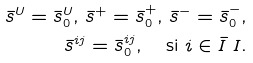Convert formula to latex. <formula><loc_0><loc_0><loc_500><loc_500>\bar { s } ^ { U } = \bar { s } _ { 0 } ^ { U } , \, \bar { s } ^ { + } = \bar { s } _ { 0 } ^ { + } , \, \bar { s } ^ { - } = \bar { s } _ { 0 } ^ { - } , \\ \bar { s } ^ { i j } = \bar { s } _ { 0 } ^ { i j } , \quad \text {si } i \in \bar { I } \ I .</formula> 